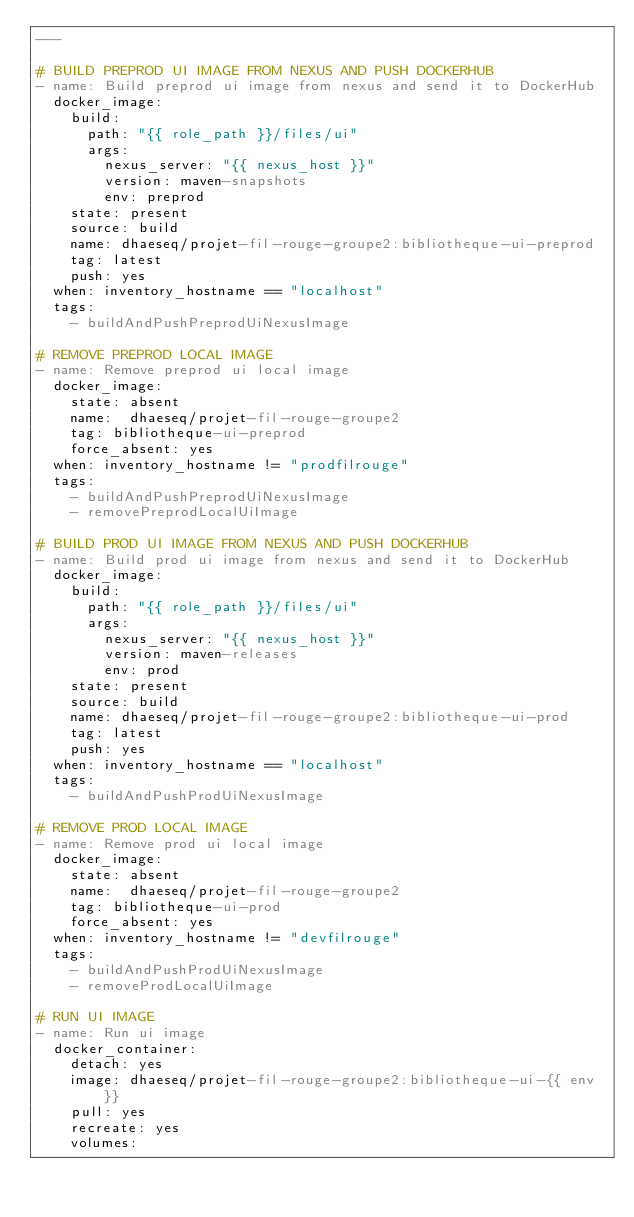Convert code to text. <code><loc_0><loc_0><loc_500><loc_500><_YAML_>---

# BUILD PREPROD UI IMAGE FROM NEXUS AND PUSH DOCKERHUB
- name: Build preprod ui image from nexus and send it to DockerHub
  docker_image:
    build:
      path: "{{ role_path }}/files/ui"
      args:
        nexus_server: "{{ nexus_host }}"
        version: maven-snapshots
        env: preprod
    state: present
    source: build
    name: dhaeseq/projet-fil-rouge-groupe2:bibliotheque-ui-preprod
    tag: latest
    push: yes
  when: inventory_hostname == "localhost"
  tags:
    - buildAndPushPreprodUiNexusImage

# REMOVE PREPROD LOCAL IMAGE
- name: Remove preprod ui local image
  docker_image:
    state: absent
    name:  dhaeseq/projet-fil-rouge-groupe2
    tag: bibliotheque-ui-preprod
    force_absent: yes
  when: inventory_hostname != "prodfilrouge"
  tags:
    - buildAndPushPreprodUiNexusImage
    - removePreprodLocalUiImage

# BUILD PROD UI IMAGE FROM NEXUS AND PUSH DOCKERHUB
- name: Build prod ui image from nexus and send it to DockerHub
  docker_image:
    build:
      path: "{{ role_path }}/files/ui"
      args:
        nexus_server: "{{ nexus_host }}"
        version: maven-releases
        env: prod
    state: present
    source: build
    name: dhaeseq/projet-fil-rouge-groupe2:bibliotheque-ui-prod
    tag: latest
    push: yes
  when: inventory_hostname == "localhost"
  tags:
    - buildAndPushProdUiNexusImage

# REMOVE PROD LOCAL IMAGE
- name: Remove prod ui local image
  docker_image:
    state: absent
    name:  dhaeseq/projet-fil-rouge-groupe2
    tag: bibliotheque-ui-prod
    force_absent: yes
  when: inventory_hostname != "devfilrouge"
  tags:
    - buildAndPushProdUiNexusImage
    - removeProdLocalUiImage

# RUN UI IMAGE
- name: Run ui image
  docker_container:
    detach: yes
    image: dhaeseq/projet-fil-rouge-groupe2:bibliotheque-ui-{{ env }}
    pull: yes
    recreate: yes
    volumes:</code> 